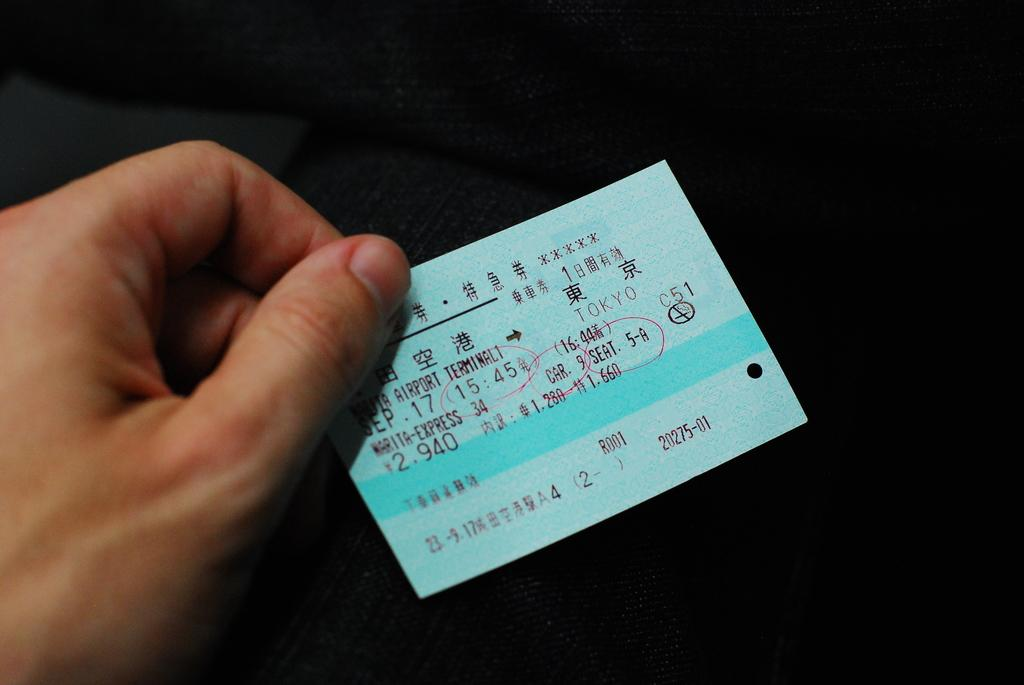What is the person holding in the image? There is a person's hand holding a slip in the image. What can be seen on the slip? The slip has some text on it. What else is visible in the background of the image? There is a cloth visible in the background of the image. Is the snake resting on the person's hand in the image? There is no snake present in the image. 